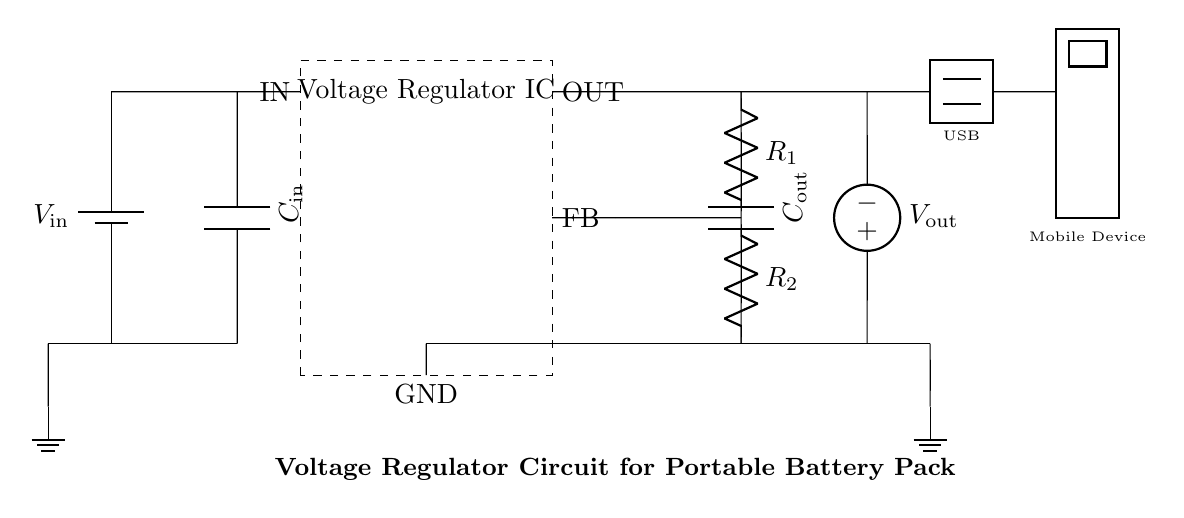What is the input voltage of this circuit? The circuit diagram indicates the input voltage is represented by the label V_in next to the battery symbol at the top left. The absence of a specific numerical value suggests a variable input depending on the battery used, but it is typically assumed to be greater than the regulated output voltage.
Answer: V_in What components are used in the voltage regulation section? The voltage regulation section of this circuit includes the Voltage Regulator IC, the input capacitor C_in, the output capacitor C_out, and the resistors R_1 and R_2 which form a voltage divider for feedback. These components work together to maintain a consistent output voltage.
Answer: Voltage Regulator IC, C_in, C_out, R_1, R_2 What is the purpose of the feedback pin labeled FB? The feedback pin FB helps control the output voltage by comparing it against a reference voltage inside the regulator IC. It ensures the output voltage remains stable despite changes in load or input voltage by adjusting the output accordingly.
Answer: Voltage regulation What is the role of the output capacitors in this circuit? The output capacitor C_out smooths out the voltage by reducing ripple and ensuring stable power delivery to the connected mobile device. It decouples the load changes and helps maintain the regulated voltage during sudden current demands.
Answer: Smoothing output voltage How is the output voltage derived in this circuit? The output voltage V_out is determined by the voltage regulator IC, which takes the input voltage V_in and regulates it down to a lower level. The resistors R_1 and R_2 set the output level via the feedback mechanism.
Answer: Regulated output voltage Which components are responsible for charging the connected mobile device? The circuit's terminal labeled V_out is connected to the USB symbol, indicating that the USB output supplies power to charge the mobile device. The voltage regulator ensures that this output is stable and appropriate for charging.
Answer: V_out 